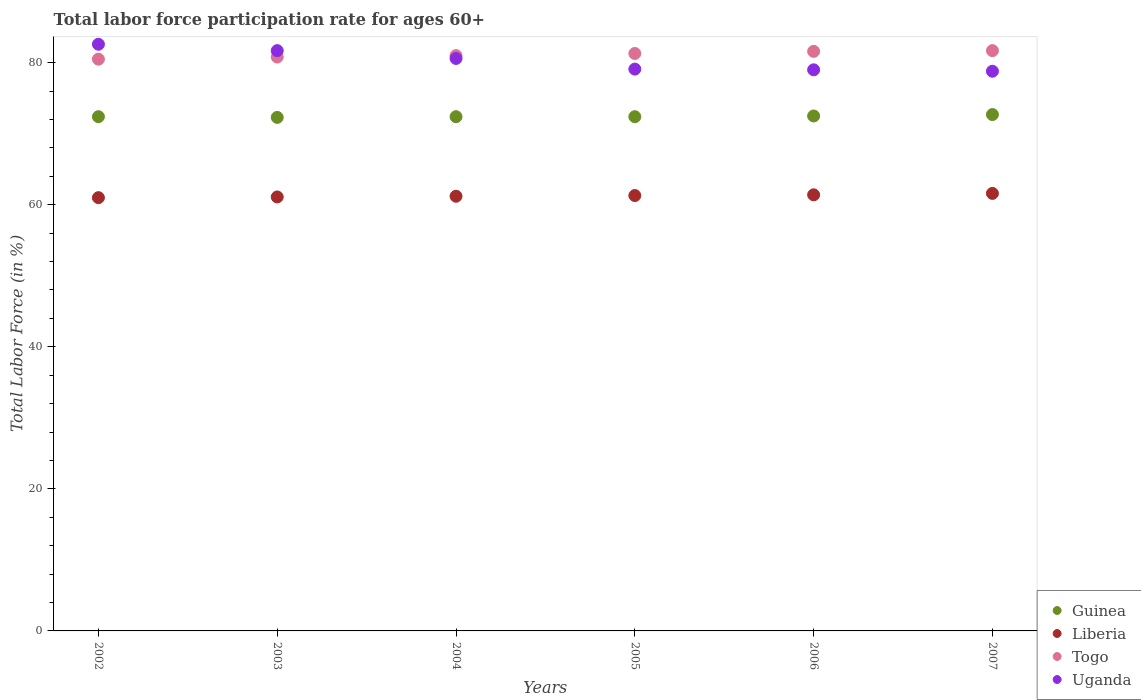What is the labor force participation rate in Uganda in 2007?
Your response must be concise. 78.8. Across all years, what is the maximum labor force participation rate in Liberia?
Offer a very short reply. 61.6. Across all years, what is the minimum labor force participation rate in Liberia?
Provide a succinct answer. 61. In which year was the labor force participation rate in Liberia minimum?
Keep it short and to the point. 2002. What is the total labor force participation rate in Liberia in the graph?
Ensure brevity in your answer.  367.6. What is the difference between the labor force participation rate in Togo in 2003 and that in 2004?
Give a very brief answer. -0.2. What is the difference between the labor force participation rate in Uganda in 2004 and the labor force participation rate in Togo in 2002?
Your answer should be compact. 0.1. What is the average labor force participation rate in Guinea per year?
Ensure brevity in your answer.  72.45. In the year 2007, what is the difference between the labor force participation rate in Liberia and labor force participation rate in Uganda?
Provide a succinct answer. -17.2. What is the ratio of the labor force participation rate in Liberia in 2003 to that in 2006?
Keep it short and to the point. 1. What is the difference between the highest and the second highest labor force participation rate in Liberia?
Offer a terse response. 0.2. What is the difference between the highest and the lowest labor force participation rate in Liberia?
Keep it short and to the point. 0.6. In how many years, is the labor force participation rate in Guinea greater than the average labor force participation rate in Guinea taken over all years?
Make the answer very short. 2. Is the sum of the labor force participation rate in Guinea in 2002 and 2004 greater than the maximum labor force participation rate in Liberia across all years?
Offer a very short reply. Yes. Is it the case that in every year, the sum of the labor force participation rate in Guinea and labor force participation rate in Togo  is greater than the labor force participation rate in Liberia?
Provide a succinct answer. Yes. Is the labor force participation rate in Guinea strictly less than the labor force participation rate in Uganda over the years?
Make the answer very short. Yes. Does the graph contain any zero values?
Your answer should be compact. No. How many legend labels are there?
Keep it short and to the point. 4. How are the legend labels stacked?
Provide a short and direct response. Vertical. What is the title of the graph?
Offer a very short reply. Total labor force participation rate for ages 60+. Does "Kosovo" appear as one of the legend labels in the graph?
Your response must be concise. No. What is the label or title of the X-axis?
Ensure brevity in your answer.  Years. What is the label or title of the Y-axis?
Your response must be concise. Total Labor Force (in %). What is the Total Labor Force (in %) of Guinea in 2002?
Offer a very short reply. 72.4. What is the Total Labor Force (in %) in Liberia in 2002?
Your answer should be compact. 61. What is the Total Labor Force (in %) of Togo in 2002?
Keep it short and to the point. 80.5. What is the Total Labor Force (in %) in Uganda in 2002?
Your answer should be compact. 82.6. What is the Total Labor Force (in %) of Guinea in 2003?
Provide a short and direct response. 72.3. What is the Total Labor Force (in %) of Liberia in 2003?
Make the answer very short. 61.1. What is the Total Labor Force (in %) of Togo in 2003?
Your answer should be compact. 80.8. What is the Total Labor Force (in %) in Uganda in 2003?
Offer a terse response. 81.7. What is the Total Labor Force (in %) in Guinea in 2004?
Offer a terse response. 72.4. What is the Total Labor Force (in %) of Liberia in 2004?
Offer a terse response. 61.2. What is the Total Labor Force (in %) in Uganda in 2004?
Offer a terse response. 80.6. What is the Total Labor Force (in %) in Guinea in 2005?
Your answer should be very brief. 72.4. What is the Total Labor Force (in %) in Liberia in 2005?
Your answer should be compact. 61.3. What is the Total Labor Force (in %) of Togo in 2005?
Give a very brief answer. 81.3. What is the Total Labor Force (in %) of Uganda in 2005?
Your answer should be very brief. 79.1. What is the Total Labor Force (in %) of Guinea in 2006?
Your response must be concise. 72.5. What is the Total Labor Force (in %) of Liberia in 2006?
Offer a terse response. 61.4. What is the Total Labor Force (in %) of Togo in 2006?
Your answer should be very brief. 81.6. What is the Total Labor Force (in %) in Uganda in 2006?
Offer a very short reply. 79. What is the Total Labor Force (in %) of Guinea in 2007?
Ensure brevity in your answer.  72.7. What is the Total Labor Force (in %) of Liberia in 2007?
Offer a very short reply. 61.6. What is the Total Labor Force (in %) in Togo in 2007?
Your answer should be compact. 81.7. What is the Total Labor Force (in %) of Uganda in 2007?
Provide a short and direct response. 78.8. Across all years, what is the maximum Total Labor Force (in %) of Guinea?
Provide a short and direct response. 72.7. Across all years, what is the maximum Total Labor Force (in %) in Liberia?
Your answer should be very brief. 61.6. Across all years, what is the maximum Total Labor Force (in %) in Togo?
Your answer should be very brief. 81.7. Across all years, what is the maximum Total Labor Force (in %) in Uganda?
Your response must be concise. 82.6. Across all years, what is the minimum Total Labor Force (in %) of Guinea?
Provide a short and direct response. 72.3. Across all years, what is the minimum Total Labor Force (in %) of Togo?
Your answer should be very brief. 80.5. Across all years, what is the minimum Total Labor Force (in %) in Uganda?
Your answer should be very brief. 78.8. What is the total Total Labor Force (in %) in Guinea in the graph?
Your answer should be compact. 434.7. What is the total Total Labor Force (in %) in Liberia in the graph?
Offer a very short reply. 367.6. What is the total Total Labor Force (in %) of Togo in the graph?
Make the answer very short. 486.9. What is the total Total Labor Force (in %) of Uganda in the graph?
Your answer should be compact. 481.8. What is the difference between the Total Labor Force (in %) of Guinea in 2002 and that in 2003?
Your response must be concise. 0.1. What is the difference between the Total Labor Force (in %) in Uganda in 2002 and that in 2003?
Your response must be concise. 0.9. What is the difference between the Total Labor Force (in %) of Liberia in 2002 and that in 2004?
Offer a terse response. -0.2. What is the difference between the Total Labor Force (in %) of Togo in 2002 and that in 2005?
Provide a succinct answer. -0.8. What is the difference between the Total Labor Force (in %) in Uganda in 2002 and that in 2005?
Keep it short and to the point. 3.5. What is the difference between the Total Labor Force (in %) in Guinea in 2002 and that in 2006?
Give a very brief answer. -0.1. What is the difference between the Total Labor Force (in %) of Uganda in 2002 and that in 2006?
Keep it short and to the point. 3.6. What is the difference between the Total Labor Force (in %) in Liberia in 2002 and that in 2007?
Offer a terse response. -0.6. What is the difference between the Total Labor Force (in %) of Liberia in 2003 and that in 2004?
Provide a short and direct response. -0.1. What is the difference between the Total Labor Force (in %) of Liberia in 2003 and that in 2005?
Give a very brief answer. -0.2. What is the difference between the Total Labor Force (in %) in Uganda in 2003 and that in 2005?
Your response must be concise. 2.6. What is the difference between the Total Labor Force (in %) of Guinea in 2003 and that in 2006?
Your response must be concise. -0.2. What is the difference between the Total Labor Force (in %) of Liberia in 2003 and that in 2006?
Give a very brief answer. -0.3. What is the difference between the Total Labor Force (in %) of Guinea in 2003 and that in 2007?
Make the answer very short. -0.4. What is the difference between the Total Labor Force (in %) of Uganda in 2003 and that in 2007?
Keep it short and to the point. 2.9. What is the difference between the Total Labor Force (in %) of Togo in 2004 and that in 2005?
Provide a short and direct response. -0.3. What is the difference between the Total Labor Force (in %) in Uganda in 2004 and that in 2005?
Give a very brief answer. 1.5. What is the difference between the Total Labor Force (in %) in Uganda in 2004 and that in 2006?
Offer a very short reply. 1.6. What is the difference between the Total Labor Force (in %) in Togo in 2004 and that in 2007?
Make the answer very short. -0.7. What is the difference between the Total Labor Force (in %) in Uganda in 2004 and that in 2007?
Ensure brevity in your answer.  1.8. What is the difference between the Total Labor Force (in %) of Liberia in 2005 and that in 2006?
Make the answer very short. -0.1. What is the difference between the Total Labor Force (in %) of Togo in 2005 and that in 2006?
Provide a succinct answer. -0.3. What is the difference between the Total Labor Force (in %) in Uganda in 2005 and that in 2006?
Offer a terse response. 0.1. What is the difference between the Total Labor Force (in %) in Guinea in 2005 and that in 2007?
Provide a short and direct response. -0.3. What is the difference between the Total Labor Force (in %) of Uganda in 2005 and that in 2007?
Keep it short and to the point. 0.3. What is the difference between the Total Labor Force (in %) in Liberia in 2006 and that in 2007?
Give a very brief answer. -0.2. What is the difference between the Total Labor Force (in %) in Liberia in 2002 and the Total Labor Force (in %) in Togo in 2003?
Your response must be concise. -19.8. What is the difference between the Total Labor Force (in %) in Liberia in 2002 and the Total Labor Force (in %) in Uganda in 2003?
Provide a short and direct response. -20.7. What is the difference between the Total Labor Force (in %) of Liberia in 2002 and the Total Labor Force (in %) of Togo in 2004?
Your response must be concise. -20. What is the difference between the Total Labor Force (in %) of Liberia in 2002 and the Total Labor Force (in %) of Uganda in 2004?
Ensure brevity in your answer.  -19.6. What is the difference between the Total Labor Force (in %) in Togo in 2002 and the Total Labor Force (in %) in Uganda in 2004?
Your answer should be very brief. -0.1. What is the difference between the Total Labor Force (in %) of Guinea in 2002 and the Total Labor Force (in %) of Togo in 2005?
Offer a very short reply. -8.9. What is the difference between the Total Labor Force (in %) in Guinea in 2002 and the Total Labor Force (in %) in Uganda in 2005?
Offer a terse response. -6.7. What is the difference between the Total Labor Force (in %) in Liberia in 2002 and the Total Labor Force (in %) in Togo in 2005?
Your response must be concise. -20.3. What is the difference between the Total Labor Force (in %) of Liberia in 2002 and the Total Labor Force (in %) of Uganda in 2005?
Provide a short and direct response. -18.1. What is the difference between the Total Labor Force (in %) of Guinea in 2002 and the Total Labor Force (in %) of Liberia in 2006?
Ensure brevity in your answer.  11. What is the difference between the Total Labor Force (in %) in Guinea in 2002 and the Total Labor Force (in %) in Togo in 2006?
Keep it short and to the point. -9.2. What is the difference between the Total Labor Force (in %) of Liberia in 2002 and the Total Labor Force (in %) of Togo in 2006?
Your response must be concise. -20.6. What is the difference between the Total Labor Force (in %) in Togo in 2002 and the Total Labor Force (in %) in Uganda in 2006?
Keep it short and to the point. 1.5. What is the difference between the Total Labor Force (in %) in Guinea in 2002 and the Total Labor Force (in %) in Liberia in 2007?
Offer a terse response. 10.8. What is the difference between the Total Labor Force (in %) of Liberia in 2002 and the Total Labor Force (in %) of Togo in 2007?
Your response must be concise. -20.7. What is the difference between the Total Labor Force (in %) in Liberia in 2002 and the Total Labor Force (in %) in Uganda in 2007?
Ensure brevity in your answer.  -17.8. What is the difference between the Total Labor Force (in %) in Liberia in 2003 and the Total Labor Force (in %) in Togo in 2004?
Ensure brevity in your answer.  -19.9. What is the difference between the Total Labor Force (in %) of Liberia in 2003 and the Total Labor Force (in %) of Uganda in 2004?
Your answer should be very brief. -19.5. What is the difference between the Total Labor Force (in %) of Guinea in 2003 and the Total Labor Force (in %) of Liberia in 2005?
Ensure brevity in your answer.  11. What is the difference between the Total Labor Force (in %) of Guinea in 2003 and the Total Labor Force (in %) of Togo in 2005?
Provide a succinct answer. -9. What is the difference between the Total Labor Force (in %) in Guinea in 2003 and the Total Labor Force (in %) in Uganda in 2005?
Make the answer very short. -6.8. What is the difference between the Total Labor Force (in %) of Liberia in 2003 and the Total Labor Force (in %) of Togo in 2005?
Provide a succinct answer. -20.2. What is the difference between the Total Labor Force (in %) of Togo in 2003 and the Total Labor Force (in %) of Uganda in 2005?
Provide a succinct answer. 1.7. What is the difference between the Total Labor Force (in %) of Liberia in 2003 and the Total Labor Force (in %) of Togo in 2006?
Make the answer very short. -20.5. What is the difference between the Total Labor Force (in %) in Liberia in 2003 and the Total Labor Force (in %) in Uganda in 2006?
Your answer should be compact. -17.9. What is the difference between the Total Labor Force (in %) of Guinea in 2003 and the Total Labor Force (in %) of Liberia in 2007?
Your response must be concise. 10.7. What is the difference between the Total Labor Force (in %) in Liberia in 2003 and the Total Labor Force (in %) in Togo in 2007?
Your answer should be very brief. -20.6. What is the difference between the Total Labor Force (in %) in Liberia in 2003 and the Total Labor Force (in %) in Uganda in 2007?
Keep it short and to the point. -17.7. What is the difference between the Total Labor Force (in %) of Togo in 2003 and the Total Labor Force (in %) of Uganda in 2007?
Give a very brief answer. 2. What is the difference between the Total Labor Force (in %) of Guinea in 2004 and the Total Labor Force (in %) of Liberia in 2005?
Make the answer very short. 11.1. What is the difference between the Total Labor Force (in %) of Guinea in 2004 and the Total Labor Force (in %) of Togo in 2005?
Your response must be concise. -8.9. What is the difference between the Total Labor Force (in %) in Liberia in 2004 and the Total Labor Force (in %) in Togo in 2005?
Offer a very short reply. -20.1. What is the difference between the Total Labor Force (in %) of Liberia in 2004 and the Total Labor Force (in %) of Uganda in 2005?
Ensure brevity in your answer.  -17.9. What is the difference between the Total Labor Force (in %) in Togo in 2004 and the Total Labor Force (in %) in Uganda in 2005?
Provide a succinct answer. 1.9. What is the difference between the Total Labor Force (in %) in Guinea in 2004 and the Total Labor Force (in %) in Liberia in 2006?
Give a very brief answer. 11. What is the difference between the Total Labor Force (in %) of Guinea in 2004 and the Total Labor Force (in %) of Uganda in 2006?
Your response must be concise. -6.6. What is the difference between the Total Labor Force (in %) of Liberia in 2004 and the Total Labor Force (in %) of Togo in 2006?
Provide a succinct answer. -20.4. What is the difference between the Total Labor Force (in %) in Liberia in 2004 and the Total Labor Force (in %) in Uganda in 2006?
Ensure brevity in your answer.  -17.8. What is the difference between the Total Labor Force (in %) in Togo in 2004 and the Total Labor Force (in %) in Uganda in 2006?
Provide a short and direct response. 2. What is the difference between the Total Labor Force (in %) in Guinea in 2004 and the Total Labor Force (in %) in Liberia in 2007?
Ensure brevity in your answer.  10.8. What is the difference between the Total Labor Force (in %) in Guinea in 2004 and the Total Labor Force (in %) in Uganda in 2007?
Your answer should be very brief. -6.4. What is the difference between the Total Labor Force (in %) in Liberia in 2004 and the Total Labor Force (in %) in Togo in 2007?
Ensure brevity in your answer.  -20.5. What is the difference between the Total Labor Force (in %) of Liberia in 2004 and the Total Labor Force (in %) of Uganda in 2007?
Your answer should be very brief. -17.6. What is the difference between the Total Labor Force (in %) of Togo in 2004 and the Total Labor Force (in %) of Uganda in 2007?
Your answer should be very brief. 2.2. What is the difference between the Total Labor Force (in %) of Guinea in 2005 and the Total Labor Force (in %) of Uganda in 2006?
Your answer should be very brief. -6.6. What is the difference between the Total Labor Force (in %) of Liberia in 2005 and the Total Labor Force (in %) of Togo in 2006?
Provide a short and direct response. -20.3. What is the difference between the Total Labor Force (in %) of Liberia in 2005 and the Total Labor Force (in %) of Uganda in 2006?
Your answer should be very brief. -17.7. What is the difference between the Total Labor Force (in %) of Togo in 2005 and the Total Labor Force (in %) of Uganda in 2006?
Offer a very short reply. 2.3. What is the difference between the Total Labor Force (in %) of Guinea in 2005 and the Total Labor Force (in %) of Togo in 2007?
Make the answer very short. -9.3. What is the difference between the Total Labor Force (in %) in Liberia in 2005 and the Total Labor Force (in %) in Togo in 2007?
Your answer should be compact. -20.4. What is the difference between the Total Labor Force (in %) of Liberia in 2005 and the Total Labor Force (in %) of Uganda in 2007?
Provide a succinct answer. -17.5. What is the difference between the Total Labor Force (in %) in Togo in 2005 and the Total Labor Force (in %) in Uganda in 2007?
Offer a terse response. 2.5. What is the difference between the Total Labor Force (in %) of Guinea in 2006 and the Total Labor Force (in %) of Liberia in 2007?
Make the answer very short. 10.9. What is the difference between the Total Labor Force (in %) of Liberia in 2006 and the Total Labor Force (in %) of Togo in 2007?
Give a very brief answer. -20.3. What is the difference between the Total Labor Force (in %) in Liberia in 2006 and the Total Labor Force (in %) in Uganda in 2007?
Ensure brevity in your answer.  -17.4. What is the difference between the Total Labor Force (in %) of Togo in 2006 and the Total Labor Force (in %) of Uganda in 2007?
Your answer should be compact. 2.8. What is the average Total Labor Force (in %) in Guinea per year?
Your answer should be very brief. 72.45. What is the average Total Labor Force (in %) in Liberia per year?
Your response must be concise. 61.27. What is the average Total Labor Force (in %) of Togo per year?
Provide a short and direct response. 81.15. What is the average Total Labor Force (in %) of Uganda per year?
Your answer should be very brief. 80.3. In the year 2002, what is the difference between the Total Labor Force (in %) in Guinea and Total Labor Force (in %) in Liberia?
Your answer should be compact. 11.4. In the year 2002, what is the difference between the Total Labor Force (in %) in Liberia and Total Labor Force (in %) in Togo?
Offer a terse response. -19.5. In the year 2002, what is the difference between the Total Labor Force (in %) in Liberia and Total Labor Force (in %) in Uganda?
Make the answer very short. -21.6. In the year 2003, what is the difference between the Total Labor Force (in %) of Guinea and Total Labor Force (in %) of Togo?
Offer a terse response. -8.5. In the year 2003, what is the difference between the Total Labor Force (in %) in Liberia and Total Labor Force (in %) in Togo?
Give a very brief answer. -19.7. In the year 2003, what is the difference between the Total Labor Force (in %) of Liberia and Total Labor Force (in %) of Uganda?
Ensure brevity in your answer.  -20.6. In the year 2004, what is the difference between the Total Labor Force (in %) of Guinea and Total Labor Force (in %) of Liberia?
Your answer should be compact. 11.2. In the year 2004, what is the difference between the Total Labor Force (in %) in Guinea and Total Labor Force (in %) in Uganda?
Provide a short and direct response. -8.2. In the year 2004, what is the difference between the Total Labor Force (in %) of Liberia and Total Labor Force (in %) of Togo?
Your response must be concise. -19.8. In the year 2004, what is the difference between the Total Labor Force (in %) of Liberia and Total Labor Force (in %) of Uganda?
Offer a terse response. -19.4. In the year 2004, what is the difference between the Total Labor Force (in %) of Togo and Total Labor Force (in %) of Uganda?
Offer a terse response. 0.4. In the year 2005, what is the difference between the Total Labor Force (in %) in Guinea and Total Labor Force (in %) in Liberia?
Ensure brevity in your answer.  11.1. In the year 2005, what is the difference between the Total Labor Force (in %) in Guinea and Total Labor Force (in %) in Togo?
Give a very brief answer. -8.9. In the year 2005, what is the difference between the Total Labor Force (in %) of Guinea and Total Labor Force (in %) of Uganda?
Offer a terse response. -6.7. In the year 2005, what is the difference between the Total Labor Force (in %) in Liberia and Total Labor Force (in %) in Togo?
Provide a succinct answer. -20. In the year 2005, what is the difference between the Total Labor Force (in %) in Liberia and Total Labor Force (in %) in Uganda?
Provide a short and direct response. -17.8. In the year 2005, what is the difference between the Total Labor Force (in %) in Togo and Total Labor Force (in %) in Uganda?
Make the answer very short. 2.2. In the year 2006, what is the difference between the Total Labor Force (in %) of Guinea and Total Labor Force (in %) of Togo?
Provide a short and direct response. -9.1. In the year 2006, what is the difference between the Total Labor Force (in %) of Guinea and Total Labor Force (in %) of Uganda?
Make the answer very short. -6.5. In the year 2006, what is the difference between the Total Labor Force (in %) in Liberia and Total Labor Force (in %) in Togo?
Provide a succinct answer. -20.2. In the year 2006, what is the difference between the Total Labor Force (in %) of Liberia and Total Labor Force (in %) of Uganda?
Offer a terse response. -17.6. In the year 2006, what is the difference between the Total Labor Force (in %) in Togo and Total Labor Force (in %) in Uganda?
Your answer should be compact. 2.6. In the year 2007, what is the difference between the Total Labor Force (in %) of Guinea and Total Labor Force (in %) of Togo?
Your answer should be very brief. -9. In the year 2007, what is the difference between the Total Labor Force (in %) of Liberia and Total Labor Force (in %) of Togo?
Give a very brief answer. -20.1. In the year 2007, what is the difference between the Total Labor Force (in %) in Liberia and Total Labor Force (in %) in Uganda?
Provide a succinct answer. -17.2. What is the ratio of the Total Labor Force (in %) of Uganda in 2002 to that in 2004?
Your answer should be compact. 1.02. What is the ratio of the Total Labor Force (in %) of Guinea in 2002 to that in 2005?
Make the answer very short. 1. What is the ratio of the Total Labor Force (in %) in Liberia in 2002 to that in 2005?
Provide a short and direct response. 1. What is the ratio of the Total Labor Force (in %) of Togo in 2002 to that in 2005?
Keep it short and to the point. 0.99. What is the ratio of the Total Labor Force (in %) of Uganda in 2002 to that in 2005?
Provide a succinct answer. 1.04. What is the ratio of the Total Labor Force (in %) in Guinea in 2002 to that in 2006?
Keep it short and to the point. 1. What is the ratio of the Total Labor Force (in %) of Togo in 2002 to that in 2006?
Give a very brief answer. 0.99. What is the ratio of the Total Labor Force (in %) in Uganda in 2002 to that in 2006?
Ensure brevity in your answer.  1.05. What is the ratio of the Total Labor Force (in %) in Liberia in 2002 to that in 2007?
Offer a very short reply. 0.99. What is the ratio of the Total Labor Force (in %) in Uganda in 2002 to that in 2007?
Your answer should be very brief. 1.05. What is the ratio of the Total Labor Force (in %) of Guinea in 2003 to that in 2004?
Your answer should be compact. 1. What is the ratio of the Total Labor Force (in %) of Liberia in 2003 to that in 2004?
Provide a succinct answer. 1. What is the ratio of the Total Labor Force (in %) in Togo in 2003 to that in 2004?
Keep it short and to the point. 1. What is the ratio of the Total Labor Force (in %) in Uganda in 2003 to that in 2004?
Offer a very short reply. 1.01. What is the ratio of the Total Labor Force (in %) in Guinea in 2003 to that in 2005?
Your answer should be very brief. 1. What is the ratio of the Total Labor Force (in %) in Togo in 2003 to that in 2005?
Provide a succinct answer. 0.99. What is the ratio of the Total Labor Force (in %) in Uganda in 2003 to that in 2005?
Keep it short and to the point. 1.03. What is the ratio of the Total Labor Force (in %) of Liberia in 2003 to that in 2006?
Your answer should be very brief. 1. What is the ratio of the Total Labor Force (in %) in Togo in 2003 to that in 2006?
Offer a terse response. 0.99. What is the ratio of the Total Labor Force (in %) of Uganda in 2003 to that in 2006?
Your answer should be compact. 1.03. What is the ratio of the Total Labor Force (in %) in Guinea in 2003 to that in 2007?
Your response must be concise. 0.99. What is the ratio of the Total Labor Force (in %) in Togo in 2003 to that in 2007?
Provide a succinct answer. 0.99. What is the ratio of the Total Labor Force (in %) in Uganda in 2003 to that in 2007?
Provide a short and direct response. 1.04. What is the ratio of the Total Labor Force (in %) of Guinea in 2004 to that in 2006?
Make the answer very short. 1. What is the ratio of the Total Labor Force (in %) of Liberia in 2004 to that in 2006?
Keep it short and to the point. 1. What is the ratio of the Total Labor Force (in %) in Uganda in 2004 to that in 2006?
Ensure brevity in your answer.  1.02. What is the ratio of the Total Labor Force (in %) of Guinea in 2004 to that in 2007?
Ensure brevity in your answer.  1. What is the ratio of the Total Labor Force (in %) in Liberia in 2004 to that in 2007?
Your response must be concise. 0.99. What is the ratio of the Total Labor Force (in %) of Togo in 2004 to that in 2007?
Provide a short and direct response. 0.99. What is the ratio of the Total Labor Force (in %) in Uganda in 2004 to that in 2007?
Your answer should be very brief. 1.02. What is the ratio of the Total Labor Force (in %) in Liberia in 2005 to that in 2006?
Make the answer very short. 1. What is the ratio of the Total Labor Force (in %) in Uganda in 2005 to that in 2006?
Your response must be concise. 1. What is the ratio of the Total Labor Force (in %) in Liberia in 2005 to that in 2007?
Offer a terse response. 1. What is the ratio of the Total Labor Force (in %) in Togo in 2005 to that in 2007?
Provide a succinct answer. 1. What is the ratio of the Total Labor Force (in %) of Uganda in 2005 to that in 2007?
Offer a terse response. 1. What is the ratio of the Total Labor Force (in %) in Liberia in 2006 to that in 2007?
Give a very brief answer. 1. What is the ratio of the Total Labor Force (in %) in Togo in 2006 to that in 2007?
Offer a very short reply. 1. What is the difference between the highest and the second highest Total Labor Force (in %) in Guinea?
Ensure brevity in your answer.  0.2. What is the difference between the highest and the second highest Total Labor Force (in %) in Togo?
Offer a terse response. 0.1. What is the difference between the highest and the second highest Total Labor Force (in %) of Uganda?
Ensure brevity in your answer.  0.9. What is the difference between the highest and the lowest Total Labor Force (in %) in Togo?
Provide a short and direct response. 1.2. 